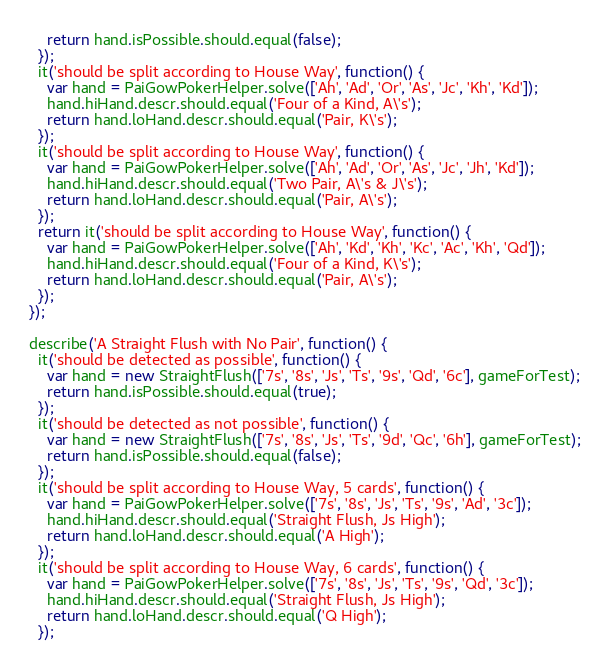<code> <loc_0><loc_0><loc_500><loc_500><_JavaScript_>    return hand.isPossible.should.equal(false);
  });
  it('should be split according to House Way', function() {
    var hand = PaiGowPokerHelper.solve(['Ah', 'Ad', 'Or', 'As', 'Jc', 'Kh', 'Kd']);
    hand.hiHand.descr.should.equal('Four of a Kind, A\'s');
    return hand.loHand.descr.should.equal('Pair, K\'s');
  });
  it('should be split according to House Way', function() {
    var hand = PaiGowPokerHelper.solve(['Ah', 'Ad', 'Or', 'As', 'Jc', 'Jh', 'Kd']);
    hand.hiHand.descr.should.equal('Two Pair, A\'s & J\'s');
    return hand.loHand.descr.should.equal('Pair, A\'s');
  });
  return it('should be split according to House Way', function() {
    var hand = PaiGowPokerHelper.solve(['Ah', 'Kd', 'Kh', 'Kc', 'Ac', 'Kh', 'Qd']);
    hand.hiHand.descr.should.equal('Four of a Kind, K\'s');
    return hand.loHand.descr.should.equal('Pair, A\'s');
  });
});

describe('A Straight Flush with No Pair', function() {
  it('should be detected as possible', function() {
    var hand = new StraightFlush(['7s', '8s', 'Js', 'Ts', '9s', 'Qd', '6c'], gameForTest);
    return hand.isPossible.should.equal(true);
  });
  it('should be detected as not possible', function() {
    var hand = new StraightFlush(['7s', '8s', 'Js', 'Ts', '9d', 'Qc', '6h'], gameForTest);
    return hand.isPossible.should.equal(false);
  });
  it('should be split according to House Way, 5 cards', function() {
    var hand = PaiGowPokerHelper.solve(['7s', '8s', 'Js', 'Ts', '9s', 'Ad', '3c']);
    hand.hiHand.descr.should.equal('Straight Flush, Js High');
    return hand.loHand.descr.should.equal('A High');
  });
  it('should be split according to House Way, 6 cards', function() {
    var hand = PaiGowPokerHelper.solve(['7s', '8s', 'Js', 'Ts', '9s', 'Qd', '3c']);
    hand.hiHand.descr.should.equal('Straight Flush, Js High');
    return hand.loHand.descr.should.equal('Q High');
  });</code> 